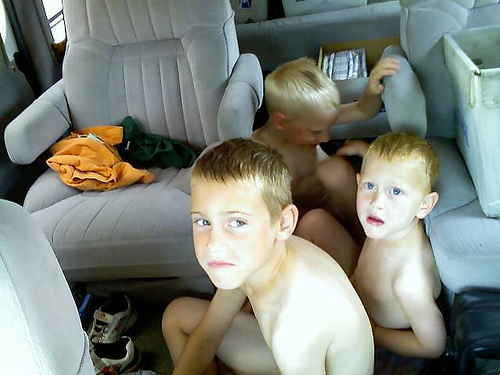<image>
Is there a hairs on the boy? No. The hairs is not positioned on the boy. They may be near each other, but the hairs is not supported by or resting on top of the boy. Is the shoe on the boy? No. The shoe is not positioned on the boy. They may be near each other, but the shoe is not supported by or resting on top of the boy. Is the chair behind the boy? Yes. From this viewpoint, the chair is positioned behind the boy, with the boy partially or fully occluding the chair. 